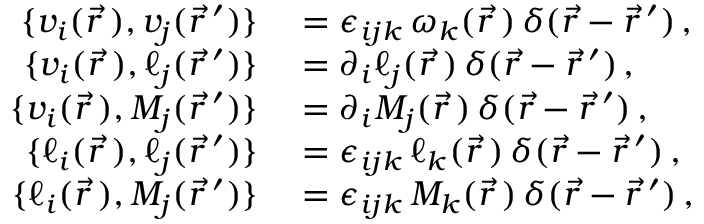<formula> <loc_0><loc_0><loc_500><loc_500>\begin{array} { r l } { \{ v _ { i } ( \vec { r \, } ) , v _ { j } ( \vec { r } \, ^ { \prime } ) \} } & = \epsilon _ { i j k } \, \omega _ { k } ( \vec { r \, } ) \, \delta ( \vec { r } - \vec { r } \, ^ { \prime } ) \, , } \\ { \{ v _ { i } ( \vec { r \, } ) , \ell _ { j } ( \vec { r } \, ^ { \prime } ) \} } & = \partial _ { i } \ell _ { j } ( \vec { r \, } ) \, \delta ( \vec { r } - \vec { r } \, ^ { \prime } ) \, , } \\ { \{ v _ { i } ( \vec { r \, } ) , M _ { j } ( \vec { r } \, ^ { \prime } ) \} } & = \partial _ { i } M _ { j } ( \vec { r \, } ) \, \delta ( \vec { r } - \vec { r } \, ^ { \prime } ) \, , } \\ { \{ \ell _ { i } ( \vec { r \, } ) , \ell _ { j } ( \vec { r } \, ^ { \prime } ) \} } & = \epsilon _ { i j k } \, \ell _ { k } ( \vec { r \, } ) \, \delta ( \vec { r } - \vec { r } \, ^ { \prime } ) \, , } \\ { \{ \ell _ { i } ( \vec { r \, } ) , M _ { j } ( \vec { r } \, ^ { \prime } ) \} } & = \epsilon _ { i j k } \, M _ { k } ( \vec { r \, } ) \, \delta ( \vec { r } - \vec { r } \, ^ { \prime } ) \, , } \end{array}</formula> 